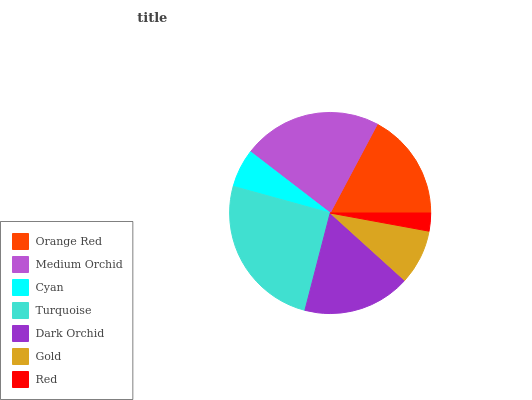Is Red the minimum?
Answer yes or no. Yes. Is Turquoise the maximum?
Answer yes or no. Yes. Is Medium Orchid the minimum?
Answer yes or no. No. Is Medium Orchid the maximum?
Answer yes or no. No. Is Medium Orchid greater than Orange Red?
Answer yes or no. Yes. Is Orange Red less than Medium Orchid?
Answer yes or no. Yes. Is Orange Red greater than Medium Orchid?
Answer yes or no. No. Is Medium Orchid less than Orange Red?
Answer yes or no. No. Is Orange Red the high median?
Answer yes or no. Yes. Is Orange Red the low median?
Answer yes or no. Yes. Is Gold the high median?
Answer yes or no. No. Is Dark Orchid the low median?
Answer yes or no. No. 